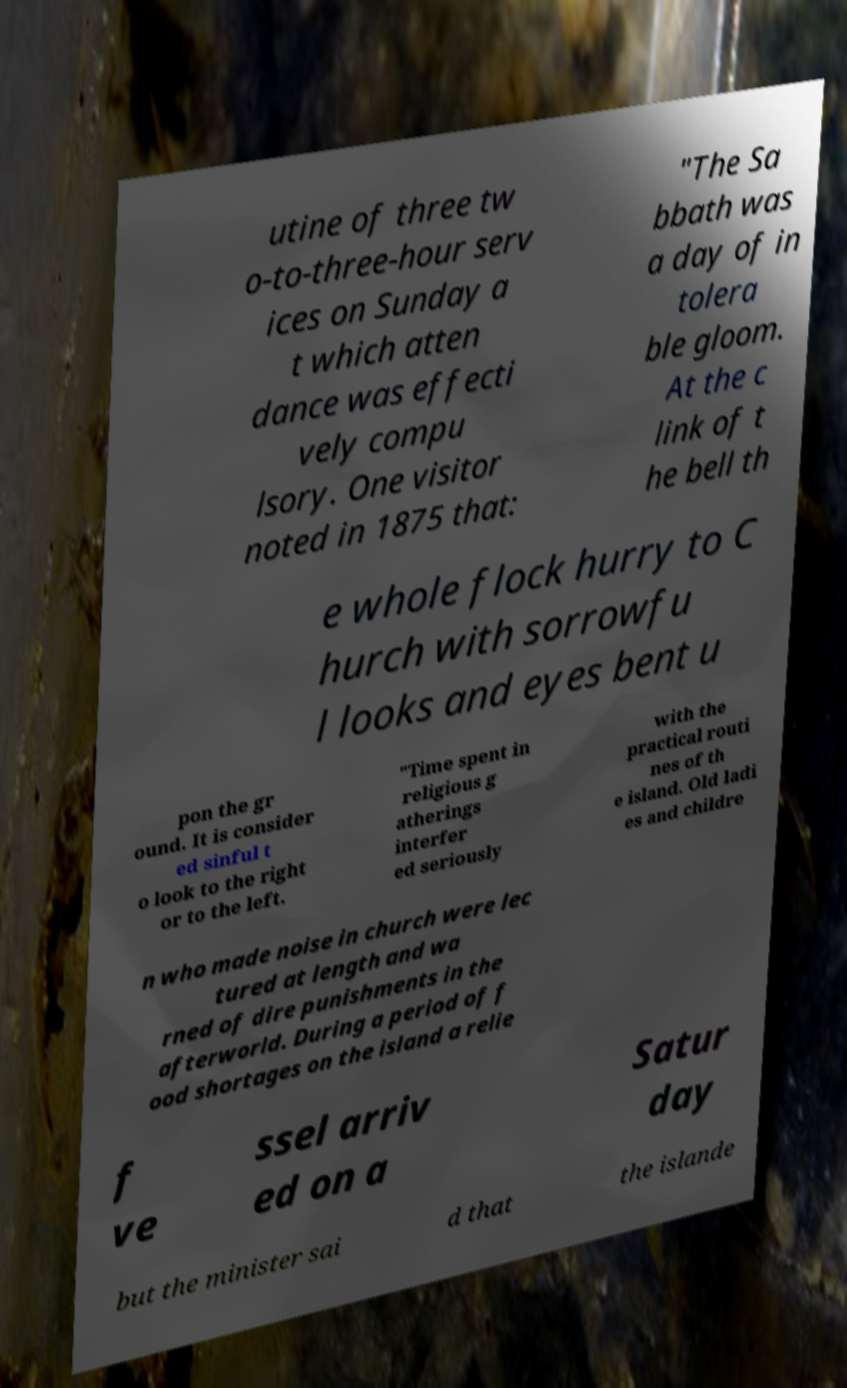I need the written content from this picture converted into text. Can you do that? utine of three tw o-to-three-hour serv ices on Sunday a t which atten dance was effecti vely compu lsory. One visitor noted in 1875 that: "The Sa bbath was a day of in tolera ble gloom. At the c link of t he bell th e whole flock hurry to C hurch with sorrowfu l looks and eyes bent u pon the gr ound. It is consider ed sinful t o look to the right or to the left. "Time spent in religious g atherings interfer ed seriously with the practical routi nes of th e island. Old ladi es and childre n who made noise in church were lec tured at length and wa rned of dire punishments in the afterworld. During a period of f ood shortages on the island a relie f ve ssel arriv ed on a Satur day but the minister sai d that the islande 